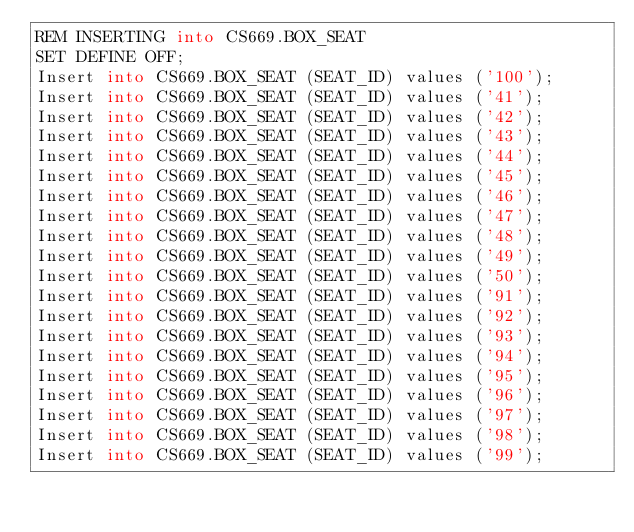Convert code to text. <code><loc_0><loc_0><loc_500><loc_500><_SQL_>REM INSERTING into CS669.BOX_SEAT
SET DEFINE OFF;
Insert into CS669.BOX_SEAT (SEAT_ID) values ('100');
Insert into CS669.BOX_SEAT (SEAT_ID) values ('41');
Insert into CS669.BOX_SEAT (SEAT_ID) values ('42');
Insert into CS669.BOX_SEAT (SEAT_ID) values ('43');
Insert into CS669.BOX_SEAT (SEAT_ID) values ('44');
Insert into CS669.BOX_SEAT (SEAT_ID) values ('45');
Insert into CS669.BOX_SEAT (SEAT_ID) values ('46');
Insert into CS669.BOX_SEAT (SEAT_ID) values ('47');
Insert into CS669.BOX_SEAT (SEAT_ID) values ('48');
Insert into CS669.BOX_SEAT (SEAT_ID) values ('49');
Insert into CS669.BOX_SEAT (SEAT_ID) values ('50');
Insert into CS669.BOX_SEAT (SEAT_ID) values ('91');
Insert into CS669.BOX_SEAT (SEAT_ID) values ('92');
Insert into CS669.BOX_SEAT (SEAT_ID) values ('93');
Insert into CS669.BOX_SEAT (SEAT_ID) values ('94');
Insert into CS669.BOX_SEAT (SEAT_ID) values ('95');
Insert into CS669.BOX_SEAT (SEAT_ID) values ('96');
Insert into CS669.BOX_SEAT (SEAT_ID) values ('97');
Insert into CS669.BOX_SEAT (SEAT_ID) values ('98');
Insert into CS669.BOX_SEAT (SEAT_ID) values ('99');
</code> 